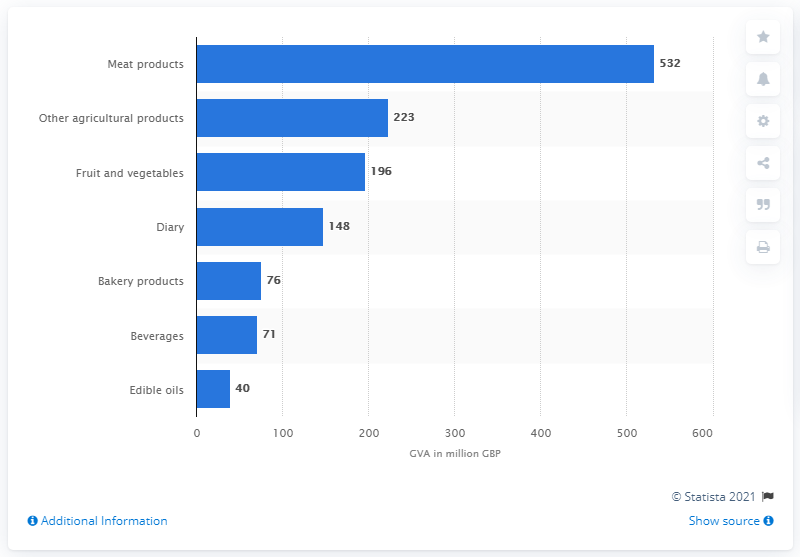Mention a couple of crucial points in this snapshot. In 2017, McDonald's in the UK spent approximately 532 million pounds on meat products. 